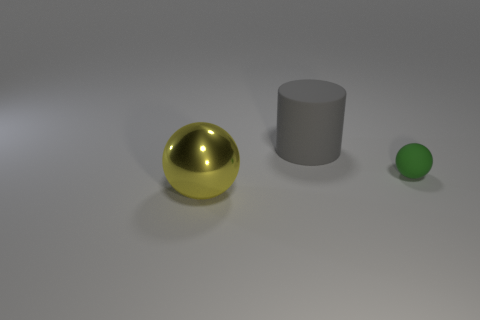Is there a big cylinder that has the same material as the green ball?
Keep it short and to the point. Yes. What is the material of the big gray cylinder?
Keep it short and to the point. Rubber. The yellow object that is in front of the thing that is to the right of the rubber object to the left of the tiny green rubber object is what shape?
Your answer should be compact. Sphere. Is the number of rubber objects left of the green thing greater than the number of tiny blue balls?
Offer a terse response. Yes. There is a large shiny object; does it have the same shape as the object that is on the right side of the matte cylinder?
Your answer should be compact. Yes. There is a big thing behind the thing to the left of the big gray object; how many yellow balls are to the left of it?
Keep it short and to the point. 1. The other metal thing that is the same size as the gray thing is what color?
Ensure brevity in your answer.  Yellow. There is a rubber object behind the matte object to the right of the rubber cylinder; what size is it?
Give a very brief answer. Large. How many other objects are there of the same size as the matte sphere?
Offer a very short reply. 0. What number of tiny red rubber balls are there?
Provide a short and direct response. 0. 